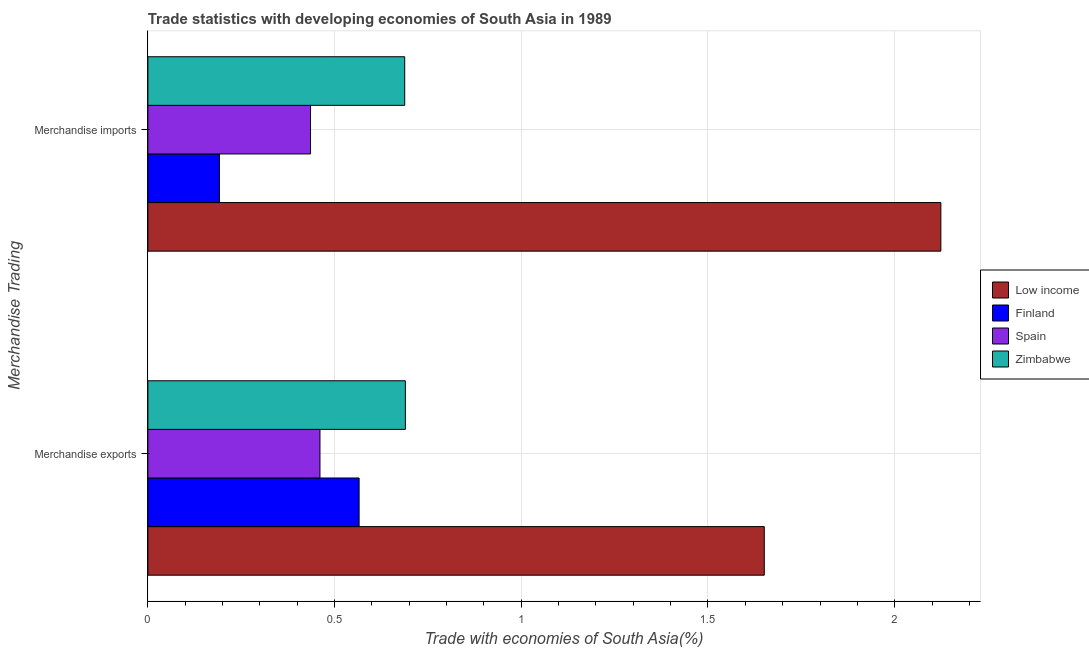How many different coloured bars are there?
Ensure brevity in your answer.  4. How many groups of bars are there?
Give a very brief answer. 2. Are the number of bars per tick equal to the number of legend labels?
Give a very brief answer. Yes. Are the number of bars on each tick of the Y-axis equal?
Your answer should be very brief. Yes. What is the label of the 2nd group of bars from the top?
Offer a terse response. Merchandise exports. What is the merchandise imports in Zimbabwe?
Provide a succinct answer. 0.69. Across all countries, what is the maximum merchandise imports?
Make the answer very short. 2.12. Across all countries, what is the minimum merchandise exports?
Offer a very short reply. 0.46. In which country was the merchandise imports maximum?
Ensure brevity in your answer.  Low income. In which country was the merchandise imports minimum?
Your answer should be very brief. Finland. What is the total merchandise imports in the graph?
Ensure brevity in your answer.  3.44. What is the difference between the merchandise imports in Spain and that in Finland?
Offer a terse response. 0.24. What is the difference between the merchandise imports in Low income and the merchandise exports in Zimbabwe?
Provide a short and direct response. 1.43. What is the average merchandise exports per country?
Offer a terse response. 0.84. What is the difference between the merchandise exports and merchandise imports in Zimbabwe?
Provide a short and direct response. 0. In how many countries, is the merchandise exports greater than 2.1 %?
Ensure brevity in your answer.  0. What is the ratio of the merchandise exports in Low income to that in Spain?
Your answer should be compact. 3.58. Are all the bars in the graph horizontal?
Ensure brevity in your answer.  Yes. How many countries are there in the graph?
Keep it short and to the point. 4. What is the difference between two consecutive major ticks on the X-axis?
Offer a very short reply. 0.5. Are the values on the major ticks of X-axis written in scientific E-notation?
Provide a succinct answer. No. Does the graph contain any zero values?
Provide a succinct answer. No. How many legend labels are there?
Make the answer very short. 4. How are the legend labels stacked?
Your response must be concise. Vertical. What is the title of the graph?
Keep it short and to the point. Trade statistics with developing economies of South Asia in 1989. What is the label or title of the X-axis?
Offer a very short reply. Trade with economies of South Asia(%). What is the label or title of the Y-axis?
Your answer should be very brief. Merchandise Trading. What is the Trade with economies of South Asia(%) in Low income in Merchandise exports?
Ensure brevity in your answer.  1.65. What is the Trade with economies of South Asia(%) in Finland in Merchandise exports?
Your answer should be very brief. 0.57. What is the Trade with economies of South Asia(%) of Spain in Merchandise exports?
Provide a succinct answer. 0.46. What is the Trade with economies of South Asia(%) of Zimbabwe in Merchandise exports?
Give a very brief answer. 0.69. What is the Trade with economies of South Asia(%) in Low income in Merchandise imports?
Ensure brevity in your answer.  2.12. What is the Trade with economies of South Asia(%) in Finland in Merchandise imports?
Offer a very short reply. 0.19. What is the Trade with economies of South Asia(%) in Spain in Merchandise imports?
Offer a terse response. 0.44. What is the Trade with economies of South Asia(%) in Zimbabwe in Merchandise imports?
Offer a terse response. 0.69. Across all Merchandise Trading, what is the maximum Trade with economies of South Asia(%) of Low income?
Offer a terse response. 2.12. Across all Merchandise Trading, what is the maximum Trade with economies of South Asia(%) of Finland?
Offer a very short reply. 0.57. Across all Merchandise Trading, what is the maximum Trade with economies of South Asia(%) in Spain?
Offer a very short reply. 0.46. Across all Merchandise Trading, what is the maximum Trade with economies of South Asia(%) of Zimbabwe?
Offer a terse response. 0.69. Across all Merchandise Trading, what is the minimum Trade with economies of South Asia(%) in Low income?
Your response must be concise. 1.65. Across all Merchandise Trading, what is the minimum Trade with economies of South Asia(%) in Finland?
Give a very brief answer. 0.19. Across all Merchandise Trading, what is the minimum Trade with economies of South Asia(%) of Spain?
Your response must be concise. 0.44. Across all Merchandise Trading, what is the minimum Trade with economies of South Asia(%) in Zimbabwe?
Your response must be concise. 0.69. What is the total Trade with economies of South Asia(%) in Low income in the graph?
Your response must be concise. 3.77. What is the total Trade with economies of South Asia(%) in Finland in the graph?
Provide a short and direct response. 0.76. What is the total Trade with economies of South Asia(%) of Spain in the graph?
Make the answer very short. 0.9. What is the total Trade with economies of South Asia(%) in Zimbabwe in the graph?
Ensure brevity in your answer.  1.38. What is the difference between the Trade with economies of South Asia(%) in Low income in Merchandise exports and that in Merchandise imports?
Keep it short and to the point. -0.47. What is the difference between the Trade with economies of South Asia(%) of Finland in Merchandise exports and that in Merchandise imports?
Offer a terse response. 0.37. What is the difference between the Trade with economies of South Asia(%) in Spain in Merchandise exports and that in Merchandise imports?
Your response must be concise. 0.03. What is the difference between the Trade with economies of South Asia(%) in Zimbabwe in Merchandise exports and that in Merchandise imports?
Offer a terse response. 0. What is the difference between the Trade with economies of South Asia(%) in Low income in Merchandise exports and the Trade with economies of South Asia(%) in Finland in Merchandise imports?
Keep it short and to the point. 1.46. What is the difference between the Trade with economies of South Asia(%) in Low income in Merchandise exports and the Trade with economies of South Asia(%) in Spain in Merchandise imports?
Your response must be concise. 1.22. What is the difference between the Trade with economies of South Asia(%) in Low income in Merchandise exports and the Trade with economies of South Asia(%) in Zimbabwe in Merchandise imports?
Your answer should be very brief. 0.96. What is the difference between the Trade with economies of South Asia(%) of Finland in Merchandise exports and the Trade with economies of South Asia(%) of Spain in Merchandise imports?
Offer a terse response. 0.13. What is the difference between the Trade with economies of South Asia(%) of Finland in Merchandise exports and the Trade with economies of South Asia(%) of Zimbabwe in Merchandise imports?
Your answer should be very brief. -0.12. What is the difference between the Trade with economies of South Asia(%) in Spain in Merchandise exports and the Trade with economies of South Asia(%) in Zimbabwe in Merchandise imports?
Provide a succinct answer. -0.23. What is the average Trade with economies of South Asia(%) of Low income per Merchandise Trading?
Your response must be concise. 1.89. What is the average Trade with economies of South Asia(%) in Finland per Merchandise Trading?
Give a very brief answer. 0.38. What is the average Trade with economies of South Asia(%) of Spain per Merchandise Trading?
Offer a very short reply. 0.45. What is the average Trade with economies of South Asia(%) of Zimbabwe per Merchandise Trading?
Give a very brief answer. 0.69. What is the difference between the Trade with economies of South Asia(%) in Low income and Trade with economies of South Asia(%) in Finland in Merchandise exports?
Your answer should be very brief. 1.09. What is the difference between the Trade with economies of South Asia(%) in Low income and Trade with economies of South Asia(%) in Spain in Merchandise exports?
Keep it short and to the point. 1.19. What is the difference between the Trade with economies of South Asia(%) in Low income and Trade with economies of South Asia(%) in Zimbabwe in Merchandise exports?
Provide a succinct answer. 0.96. What is the difference between the Trade with economies of South Asia(%) of Finland and Trade with economies of South Asia(%) of Spain in Merchandise exports?
Make the answer very short. 0.1. What is the difference between the Trade with economies of South Asia(%) in Finland and Trade with economies of South Asia(%) in Zimbabwe in Merchandise exports?
Give a very brief answer. -0.12. What is the difference between the Trade with economies of South Asia(%) of Spain and Trade with economies of South Asia(%) of Zimbabwe in Merchandise exports?
Your answer should be very brief. -0.23. What is the difference between the Trade with economies of South Asia(%) of Low income and Trade with economies of South Asia(%) of Finland in Merchandise imports?
Give a very brief answer. 1.93. What is the difference between the Trade with economies of South Asia(%) of Low income and Trade with economies of South Asia(%) of Spain in Merchandise imports?
Offer a terse response. 1.69. What is the difference between the Trade with economies of South Asia(%) of Low income and Trade with economies of South Asia(%) of Zimbabwe in Merchandise imports?
Give a very brief answer. 1.44. What is the difference between the Trade with economies of South Asia(%) in Finland and Trade with economies of South Asia(%) in Spain in Merchandise imports?
Provide a short and direct response. -0.24. What is the difference between the Trade with economies of South Asia(%) of Finland and Trade with economies of South Asia(%) of Zimbabwe in Merchandise imports?
Give a very brief answer. -0.5. What is the difference between the Trade with economies of South Asia(%) in Spain and Trade with economies of South Asia(%) in Zimbabwe in Merchandise imports?
Keep it short and to the point. -0.25. What is the ratio of the Trade with economies of South Asia(%) of Low income in Merchandise exports to that in Merchandise imports?
Provide a succinct answer. 0.78. What is the ratio of the Trade with economies of South Asia(%) in Finland in Merchandise exports to that in Merchandise imports?
Ensure brevity in your answer.  2.95. What is the ratio of the Trade with economies of South Asia(%) of Spain in Merchandise exports to that in Merchandise imports?
Give a very brief answer. 1.06. What is the difference between the highest and the second highest Trade with economies of South Asia(%) in Low income?
Ensure brevity in your answer.  0.47. What is the difference between the highest and the second highest Trade with economies of South Asia(%) of Finland?
Your answer should be very brief. 0.37. What is the difference between the highest and the second highest Trade with economies of South Asia(%) in Spain?
Offer a very short reply. 0.03. What is the difference between the highest and the second highest Trade with economies of South Asia(%) of Zimbabwe?
Provide a short and direct response. 0. What is the difference between the highest and the lowest Trade with economies of South Asia(%) in Low income?
Keep it short and to the point. 0.47. What is the difference between the highest and the lowest Trade with economies of South Asia(%) of Finland?
Give a very brief answer. 0.37. What is the difference between the highest and the lowest Trade with economies of South Asia(%) of Spain?
Ensure brevity in your answer.  0.03. What is the difference between the highest and the lowest Trade with economies of South Asia(%) in Zimbabwe?
Your answer should be very brief. 0. 